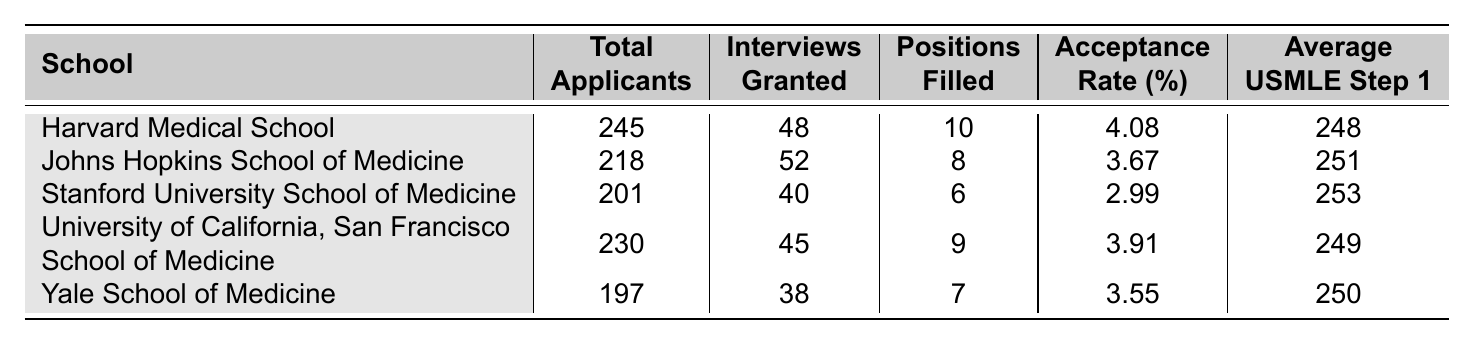What is the acceptance rate for Harvard Medical School? From the table, the acceptance rate for Harvard Medical School is listed directly under the "Acceptance Rate (%)" column, which shows 4.08%.
Answer: 4.08% Which school had the highest average USMLE Step 1 score? By comparing the values in the "Average USMLE Step 1" column, Stanford University School of Medicine has the highest score of 253.
Answer: Stanford University School of Medicine How many positions were filled at Johns Hopkins School of Medicine? The "Positions Filled" column indicates that 8 positions were filled at Johns Hopkins School of Medicine.
Answer: 8 What is the total number of applicants across all the schools? To find the total, sum the "Total Applicants" column values: 245 + 218 + 201 + 230 + 197 = 1091.
Answer: 1091 What is the average acceptance rate of all the schools? Compute the average acceptance rate by summing the individual acceptance rates (4.08 + 3.67 + 2.99 + 3.91 + 3.55) and dividing by the number of schools (5): (4.08 + 3.67 + 2.99 + 3.91 + 3.55) / 5 = 3.84.
Answer: 3.84 Is the acceptance rate for Yale School of Medicine higher than 4%? The acceptance rate for Yale School of Medicine is 3.55%, which is less than 4%, thus the statement is false.
Answer: No What is the difference in the average USMLE Step 1 score between the highest and the lowest scoring schools? The highest is Stanford with 253 and the lowest is Harvard with 248. The difference is 253 - 248 = 5.
Answer: 5 If we consider the number of interviews granted, which school had only 40 interviews? Looking at the "Interviews Granted" column, Stanford University School of Medicine had 40 interviews granted.
Answer: Stanford University School of Medicine Which school has the lowest total applicants, and how many were there? Reviewing the "Total Applicants" column, Yale School of Medicine has the lowest number with 197 applicants.
Answer: Yale School of Medicine, 197 What percentage of applicants received interviews at the University of California, San Francisco School of Medicine? Calculate by dividing the number of interviews granted (45) by the total applicants (230) and multiplying by 100: (45/230) * 100 = 19.57%.
Answer: 19.57% 